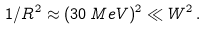Convert formula to latex. <formula><loc_0><loc_0><loc_500><loc_500>1 / R ^ { 2 } \approx ( 3 0 \, M e V ) ^ { 2 } \ll W ^ { 2 } \, .</formula> 